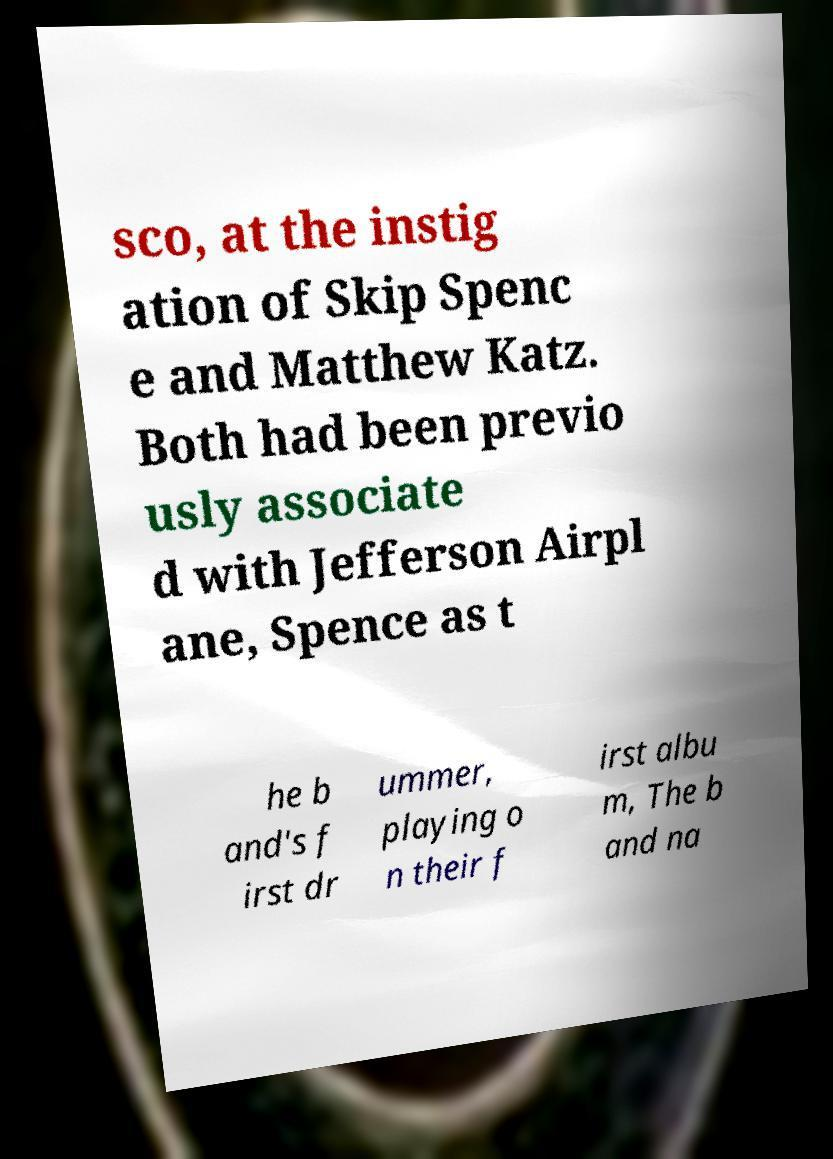Can you accurately transcribe the text from the provided image for me? sco, at the instig ation of Skip Spenc e and Matthew Katz. Both had been previo usly associate d with Jefferson Airpl ane, Spence as t he b and's f irst dr ummer, playing o n their f irst albu m, The b and na 